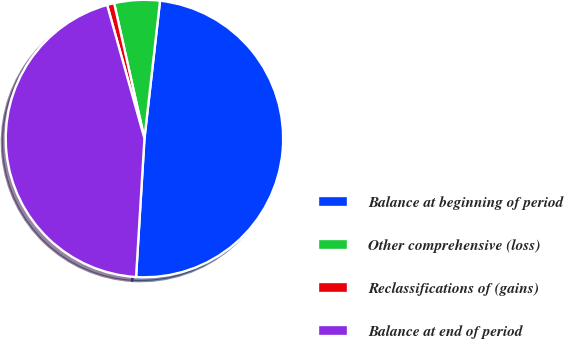Convert chart to OTSL. <chart><loc_0><loc_0><loc_500><loc_500><pie_chart><fcel>Balance at beginning of period<fcel>Other comprehensive (loss)<fcel>Reclassifications of (gains)<fcel>Balance at end of period<nl><fcel>49.17%<fcel>5.3%<fcel>0.83%<fcel>44.7%<nl></chart> 